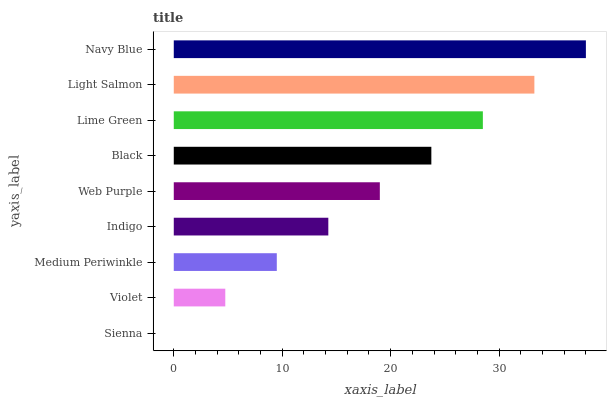Is Sienna the minimum?
Answer yes or no. Yes. Is Navy Blue the maximum?
Answer yes or no. Yes. Is Violet the minimum?
Answer yes or no. No. Is Violet the maximum?
Answer yes or no. No. Is Violet greater than Sienna?
Answer yes or no. Yes. Is Sienna less than Violet?
Answer yes or no. Yes. Is Sienna greater than Violet?
Answer yes or no. No. Is Violet less than Sienna?
Answer yes or no. No. Is Web Purple the high median?
Answer yes or no. Yes. Is Web Purple the low median?
Answer yes or no. Yes. Is Indigo the high median?
Answer yes or no. No. Is Violet the low median?
Answer yes or no. No. 